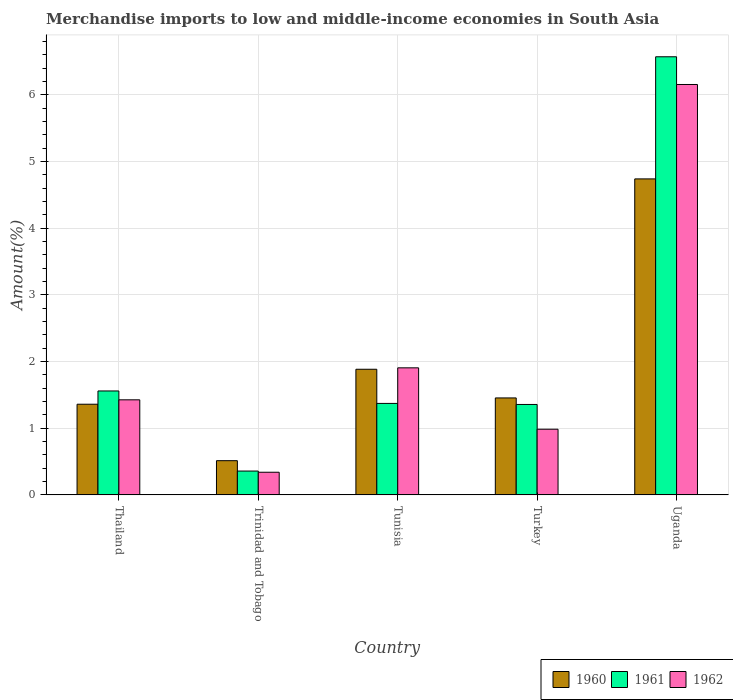How many different coloured bars are there?
Keep it short and to the point. 3. How many groups of bars are there?
Make the answer very short. 5. Are the number of bars per tick equal to the number of legend labels?
Give a very brief answer. Yes. What is the label of the 3rd group of bars from the left?
Offer a very short reply. Tunisia. In how many cases, is the number of bars for a given country not equal to the number of legend labels?
Offer a very short reply. 0. What is the percentage of amount earned from merchandise imports in 1962 in Thailand?
Your answer should be very brief. 1.43. Across all countries, what is the maximum percentage of amount earned from merchandise imports in 1960?
Make the answer very short. 4.74. Across all countries, what is the minimum percentage of amount earned from merchandise imports in 1962?
Provide a short and direct response. 0.34. In which country was the percentage of amount earned from merchandise imports in 1960 maximum?
Offer a terse response. Uganda. In which country was the percentage of amount earned from merchandise imports in 1961 minimum?
Your response must be concise. Trinidad and Tobago. What is the total percentage of amount earned from merchandise imports in 1961 in the graph?
Make the answer very short. 11.21. What is the difference between the percentage of amount earned from merchandise imports in 1962 in Trinidad and Tobago and that in Uganda?
Ensure brevity in your answer.  -5.81. What is the difference between the percentage of amount earned from merchandise imports in 1961 in Turkey and the percentage of amount earned from merchandise imports in 1960 in Trinidad and Tobago?
Your answer should be compact. 0.84. What is the average percentage of amount earned from merchandise imports in 1960 per country?
Give a very brief answer. 1.99. What is the difference between the percentage of amount earned from merchandise imports of/in 1962 and percentage of amount earned from merchandise imports of/in 1961 in Thailand?
Ensure brevity in your answer.  -0.13. In how many countries, is the percentage of amount earned from merchandise imports in 1962 greater than 3.4 %?
Your answer should be very brief. 1. What is the ratio of the percentage of amount earned from merchandise imports in 1961 in Thailand to that in Tunisia?
Ensure brevity in your answer.  1.14. Is the percentage of amount earned from merchandise imports in 1961 in Thailand less than that in Turkey?
Your answer should be compact. No. Is the difference between the percentage of amount earned from merchandise imports in 1962 in Trinidad and Tobago and Tunisia greater than the difference between the percentage of amount earned from merchandise imports in 1961 in Trinidad and Tobago and Tunisia?
Keep it short and to the point. No. What is the difference between the highest and the second highest percentage of amount earned from merchandise imports in 1961?
Offer a very short reply. 0.19. What is the difference between the highest and the lowest percentage of amount earned from merchandise imports in 1962?
Provide a short and direct response. 5.81. What does the 1st bar from the right in Thailand represents?
Offer a very short reply. 1962. Is it the case that in every country, the sum of the percentage of amount earned from merchandise imports in 1960 and percentage of amount earned from merchandise imports in 1961 is greater than the percentage of amount earned from merchandise imports in 1962?
Provide a short and direct response. Yes. How many countries are there in the graph?
Your response must be concise. 5. What is the difference between two consecutive major ticks on the Y-axis?
Make the answer very short. 1. Does the graph contain grids?
Offer a terse response. Yes. Where does the legend appear in the graph?
Offer a very short reply. Bottom right. How are the legend labels stacked?
Make the answer very short. Horizontal. What is the title of the graph?
Offer a terse response. Merchandise imports to low and middle-income economies in South Asia. Does "1960" appear as one of the legend labels in the graph?
Offer a terse response. Yes. What is the label or title of the Y-axis?
Your response must be concise. Amount(%). What is the Amount(%) in 1960 in Thailand?
Provide a short and direct response. 1.36. What is the Amount(%) of 1961 in Thailand?
Ensure brevity in your answer.  1.56. What is the Amount(%) of 1962 in Thailand?
Provide a short and direct response. 1.43. What is the Amount(%) of 1960 in Trinidad and Tobago?
Ensure brevity in your answer.  0.51. What is the Amount(%) in 1961 in Trinidad and Tobago?
Ensure brevity in your answer.  0.36. What is the Amount(%) in 1962 in Trinidad and Tobago?
Your answer should be very brief. 0.34. What is the Amount(%) in 1960 in Tunisia?
Your response must be concise. 1.88. What is the Amount(%) of 1961 in Tunisia?
Your response must be concise. 1.37. What is the Amount(%) of 1962 in Tunisia?
Provide a short and direct response. 1.91. What is the Amount(%) in 1960 in Turkey?
Your answer should be very brief. 1.45. What is the Amount(%) in 1961 in Turkey?
Keep it short and to the point. 1.36. What is the Amount(%) in 1962 in Turkey?
Offer a terse response. 0.98. What is the Amount(%) in 1960 in Uganda?
Your answer should be very brief. 4.74. What is the Amount(%) of 1961 in Uganda?
Provide a succinct answer. 6.57. What is the Amount(%) in 1962 in Uganda?
Provide a succinct answer. 6.15. Across all countries, what is the maximum Amount(%) in 1960?
Make the answer very short. 4.74. Across all countries, what is the maximum Amount(%) in 1961?
Ensure brevity in your answer.  6.57. Across all countries, what is the maximum Amount(%) of 1962?
Offer a very short reply. 6.15. Across all countries, what is the minimum Amount(%) of 1960?
Your answer should be compact. 0.51. Across all countries, what is the minimum Amount(%) in 1961?
Provide a short and direct response. 0.36. Across all countries, what is the minimum Amount(%) of 1962?
Make the answer very short. 0.34. What is the total Amount(%) of 1960 in the graph?
Provide a short and direct response. 9.95. What is the total Amount(%) of 1961 in the graph?
Provide a short and direct response. 11.21. What is the total Amount(%) of 1962 in the graph?
Ensure brevity in your answer.  10.81. What is the difference between the Amount(%) in 1960 in Thailand and that in Trinidad and Tobago?
Provide a short and direct response. 0.85. What is the difference between the Amount(%) in 1961 in Thailand and that in Trinidad and Tobago?
Your response must be concise. 1.2. What is the difference between the Amount(%) of 1962 in Thailand and that in Trinidad and Tobago?
Provide a short and direct response. 1.09. What is the difference between the Amount(%) of 1960 in Thailand and that in Tunisia?
Keep it short and to the point. -0.52. What is the difference between the Amount(%) of 1961 in Thailand and that in Tunisia?
Provide a short and direct response. 0.19. What is the difference between the Amount(%) of 1962 in Thailand and that in Tunisia?
Your response must be concise. -0.48. What is the difference between the Amount(%) in 1960 in Thailand and that in Turkey?
Your answer should be very brief. -0.09. What is the difference between the Amount(%) in 1961 in Thailand and that in Turkey?
Give a very brief answer. 0.2. What is the difference between the Amount(%) of 1962 in Thailand and that in Turkey?
Your response must be concise. 0.44. What is the difference between the Amount(%) of 1960 in Thailand and that in Uganda?
Give a very brief answer. -3.38. What is the difference between the Amount(%) of 1961 in Thailand and that in Uganda?
Your answer should be very brief. -5.01. What is the difference between the Amount(%) in 1962 in Thailand and that in Uganda?
Provide a succinct answer. -4.73. What is the difference between the Amount(%) of 1960 in Trinidad and Tobago and that in Tunisia?
Your answer should be very brief. -1.37. What is the difference between the Amount(%) in 1961 in Trinidad and Tobago and that in Tunisia?
Provide a short and direct response. -1.01. What is the difference between the Amount(%) in 1962 in Trinidad and Tobago and that in Tunisia?
Give a very brief answer. -1.57. What is the difference between the Amount(%) in 1960 in Trinidad and Tobago and that in Turkey?
Ensure brevity in your answer.  -0.94. What is the difference between the Amount(%) of 1961 in Trinidad and Tobago and that in Turkey?
Your response must be concise. -1. What is the difference between the Amount(%) in 1962 in Trinidad and Tobago and that in Turkey?
Your response must be concise. -0.65. What is the difference between the Amount(%) of 1960 in Trinidad and Tobago and that in Uganda?
Make the answer very short. -4.23. What is the difference between the Amount(%) in 1961 in Trinidad and Tobago and that in Uganda?
Ensure brevity in your answer.  -6.21. What is the difference between the Amount(%) of 1962 in Trinidad and Tobago and that in Uganda?
Give a very brief answer. -5.81. What is the difference between the Amount(%) of 1960 in Tunisia and that in Turkey?
Provide a succinct answer. 0.43. What is the difference between the Amount(%) in 1961 in Tunisia and that in Turkey?
Make the answer very short. 0.02. What is the difference between the Amount(%) in 1962 in Tunisia and that in Turkey?
Your response must be concise. 0.92. What is the difference between the Amount(%) of 1960 in Tunisia and that in Uganda?
Your answer should be compact. -2.85. What is the difference between the Amount(%) in 1961 in Tunisia and that in Uganda?
Provide a short and direct response. -5.2. What is the difference between the Amount(%) in 1962 in Tunisia and that in Uganda?
Your answer should be compact. -4.25. What is the difference between the Amount(%) of 1960 in Turkey and that in Uganda?
Ensure brevity in your answer.  -3.28. What is the difference between the Amount(%) of 1961 in Turkey and that in Uganda?
Keep it short and to the point. -5.21. What is the difference between the Amount(%) of 1962 in Turkey and that in Uganda?
Your answer should be compact. -5.17. What is the difference between the Amount(%) in 1960 in Thailand and the Amount(%) in 1961 in Trinidad and Tobago?
Your response must be concise. 1. What is the difference between the Amount(%) of 1960 in Thailand and the Amount(%) of 1962 in Trinidad and Tobago?
Give a very brief answer. 1.02. What is the difference between the Amount(%) of 1961 in Thailand and the Amount(%) of 1962 in Trinidad and Tobago?
Your response must be concise. 1.22. What is the difference between the Amount(%) of 1960 in Thailand and the Amount(%) of 1961 in Tunisia?
Your response must be concise. -0.01. What is the difference between the Amount(%) of 1960 in Thailand and the Amount(%) of 1962 in Tunisia?
Make the answer very short. -0.55. What is the difference between the Amount(%) of 1961 in Thailand and the Amount(%) of 1962 in Tunisia?
Keep it short and to the point. -0.35. What is the difference between the Amount(%) in 1960 in Thailand and the Amount(%) in 1961 in Turkey?
Offer a very short reply. 0. What is the difference between the Amount(%) in 1960 in Thailand and the Amount(%) in 1962 in Turkey?
Provide a short and direct response. 0.37. What is the difference between the Amount(%) of 1961 in Thailand and the Amount(%) of 1962 in Turkey?
Give a very brief answer. 0.57. What is the difference between the Amount(%) of 1960 in Thailand and the Amount(%) of 1961 in Uganda?
Keep it short and to the point. -5.21. What is the difference between the Amount(%) in 1960 in Thailand and the Amount(%) in 1962 in Uganda?
Your answer should be very brief. -4.79. What is the difference between the Amount(%) in 1961 in Thailand and the Amount(%) in 1962 in Uganda?
Your response must be concise. -4.6. What is the difference between the Amount(%) in 1960 in Trinidad and Tobago and the Amount(%) in 1961 in Tunisia?
Offer a very short reply. -0.86. What is the difference between the Amount(%) of 1960 in Trinidad and Tobago and the Amount(%) of 1962 in Tunisia?
Provide a short and direct response. -1.39. What is the difference between the Amount(%) in 1961 in Trinidad and Tobago and the Amount(%) in 1962 in Tunisia?
Offer a very short reply. -1.55. What is the difference between the Amount(%) in 1960 in Trinidad and Tobago and the Amount(%) in 1961 in Turkey?
Your answer should be compact. -0.84. What is the difference between the Amount(%) in 1960 in Trinidad and Tobago and the Amount(%) in 1962 in Turkey?
Ensure brevity in your answer.  -0.47. What is the difference between the Amount(%) in 1961 in Trinidad and Tobago and the Amount(%) in 1962 in Turkey?
Ensure brevity in your answer.  -0.63. What is the difference between the Amount(%) of 1960 in Trinidad and Tobago and the Amount(%) of 1961 in Uganda?
Your answer should be compact. -6.06. What is the difference between the Amount(%) in 1960 in Trinidad and Tobago and the Amount(%) in 1962 in Uganda?
Make the answer very short. -5.64. What is the difference between the Amount(%) of 1961 in Trinidad and Tobago and the Amount(%) of 1962 in Uganda?
Provide a succinct answer. -5.8. What is the difference between the Amount(%) of 1960 in Tunisia and the Amount(%) of 1961 in Turkey?
Give a very brief answer. 0.53. What is the difference between the Amount(%) of 1960 in Tunisia and the Amount(%) of 1962 in Turkey?
Keep it short and to the point. 0.9. What is the difference between the Amount(%) in 1961 in Tunisia and the Amount(%) in 1962 in Turkey?
Keep it short and to the point. 0.39. What is the difference between the Amount(%) in 1960 in Tunisia and the Amount(%) in 1961 in Uganda?
Provide a succinct answer. -4.69. What is the difference between the Amount(%) in 1960 in Tunisia and the Amount(%) in 1962 in Uganda?
Offer a very short reply. -4.27. What is the difference between the Amount(%) in 1961 in Tunisia and the Amount(%) in 1962 in Uganda?
Your answer should be compact. -4.78. What is the difference between the Amount(%) of 1960 in Turkey and the Amount(%) of 1961 in Uganda?
Your answer should be compact. -5.12. What is the difference between the Amount(%) in 1960 in Turkey and the Amount(%) in 1962 in Uganda?
Keep it short and to the point. -4.7. What is the difference between the Amount(%) of 1961 in Turkey and the Amount(%) of 1962 in Uganda?
Ensure brevity in your answer.  -4.8. What is the average Amount(%) of 1960 per country?
Your answer should be very brief. 1.99. What is the average Amount(%) of 1961 per country?
Offer a terse response. 2.24. What is the average Amount(%) in 1962 per country?
Keep it short and to the point. 2.16. What is the difference between the Amount(%) in 1960 and Amount(%) in 1961 in Thailand?
Your answer should be very brief. -0.2. What is the difference between the Amount(%) in 1960 and Amount(%) in 1962 in Thailand?
Your answer should be very brief. -0.07. What is the difference between the Amount(%) of 1961 and Amount(%) of 1962 in Thailand?
Your answer should be compact. 0.13. What is the difference between the Amount(%) of 1960 and Amount(%) of 1961 in Trinidad and Tobago?
Your answer should be very brief. 0.16. What is the difference between the Amount(%) of 1960 and Amount(%) of 1962 in Trinidad and Tobago?
Offer a terse response. 0.17. What is the difference between the Amount(%) in 1961 and Amount(%) in 1962 in Trinidad and Tobago?
Your answer should be compact. 0.02. What is the difference between the Amount(%) of 1960 and Amount(%) of 1961 in Tunisia?
Ensure brevity in your answer.  0.51. What is the difference between the Amount(%) of 1960 and Amount(%) of 1962 in Tunisia?
Your answer should be very brief. -0.02. What is the difference between the Amount(%) of 1961 and Amount(%) of 1962 in Tunisia?
Offer a terse response. -0.53. What is the difference between the Amount(%) in 1960 and Amount(%) in 1961 in Turkey?
Your response must be concise. 0.1. What is the difference between the Amount(%) of 1960 and Amount(%) of 1962 in Turkey?
Offer a very short reply. 0.47. What is the difference between the Amount(%) of 1961 and Amount(%) of 1962 in Turkey?
Your response must be concise. 0.37. What is the difference between the Amount(%) of 1960 and Amount(%) of 1961 in Uganda?
Your answer should be compact. -1.83. What is the difference between the Amount(%) of 1960 and Amount(%) of 1962 in Uganda?
Offer a very short reply. -1.42. What is the difference between the Amount(%) of 1961 and Amount(%) of 1962 in Uganda?
Your answer should be compact. 0.42. What is the ratio of the Amount(%) in 1960 in Thailand to that in Trinidad and Tobago?
Your response must be concise. 2.65. What is the ratio of the Amount(%) in 1961 in Thailand to that in Trinidad and Tobago?
Your answer should be very brief. 4.36. What is the ratio of the Amount(%) in 1962 in Thailand to that in Trinidad and Tobago?
Make the answer very short. 4.2. What is the ratio of the Amount(%) of 1960 in Thailand to that in Tunisia?
Make the answer very short. 0.72. What is the ratio of the Amount(%) in 1961 in Thailand to that in Tunisia?
Provide a succinct answer. 1.14. What is the ratio of the Amount(%) in 1962 in Thailand to that in Tunisia?
Provide a succinct answer. 0.75. What is the ratio of the Amount(%) of 1960 in Thailand to that in Turkey?
Provide a succinct answer. 0.94. What is the ratio of the Amount(%) in 1961 in Thailand to that in Turkey?
Make the answer very short. 1.15. What is the ratio of the Amount(%) in 1962 in Thailand to that in Turkey?
Your response must be concise. 1.45. What is the ratio of the Amount(%) in 1960 in Thailand to that in Uganda?
Provide a succinct answer. 0.29. What is the ratio of the Amount(%) of 1961 in Thailand to that in Uganda?
Your answer should be compact. 0.24. What is the ratio of the Amount(%) in 1962 in Thailand to that in Uganda?
Keep it short and to the point. 0.23. What is the ratio of the Amount(%) in 1960 in Trinidad and Tobago to that in Tunisia?
Your answer should be very brief. 0.27. What is the ratio of the Amount(%) of 1961 in Trinidad and Tobago to that in Tunisia?
Offer a terse response. 0.26. What is the ratio of the Amount(%) in 1962 in Trinidad and Tobago to that in Tunisia?
Your answer should be compact. 0.18. What is the ratio of the Amount(%) in 1960 in Trinidad and Tobago to that in Turkey?
Keep it short and to the point. 0.35. What is the ratio of the Amount(%) in 1961 in Trinidad and Tobago to that in Turkey?
Give a very brief answer. 0.26. What is the ratio of the Amount(%) of 1962 in Trinidad and Tobago to that in Turkey?
Offer a terse response. 0.34. What is the ratio of the Amount(%) of 1960 in Trinidad and Tobago to that in Uganda?
Your response must be concise. 0.11. What is the ratio of the Amount(%) of 1961 in Trinidad and Tobago to that in Uganda?
Give a very brief answer. 0.05. What is the ratio of the Amount(%) of 1962 in Trinidad and Tobago to that in Uganda?
Give a very brief answer. 0.06. What is the ratio of the Amount(%) of 1960 in Tunisia to that in Turkey?
Keep it short and to the point. 1.3. What is the ratio of the Amount(%) in 1961 in Tunisia to that in Turkey?
Provide a short and direct response. 1.01. What is the ratio of the Amount(%) of 1962 in Tunisia to that in Turkey?
Give a very brief answer. 1.93. What is the ratio of the Amount(%) of 1960 in Tunisia to that in Uganda?
Provide a short and direct response. 0.4. What is the ratio of the Amount(%) in 1961 in Tunisia to that in Uganda?
Make the answer very short. 0.21. What is the ratio of the Amount(%) in 1962 in Tunisia to that in Uganda?
Offer a terse response. 0.31. What is the ratio of the Amount(%) in 1960 in Turkey to that in Uganda?
Give a very brief answer. 0.31. What is the ratio of the Amount(%) of 1961 in Turkey to that in Uganda?
Your answer should be compact. 0.21. What is the ratio of the Amount(%) of 1962 in Turkey to that in Uganda?
Your answer should be compact. 0.16. What is the difference between the highest and the second highest Amount(%) in 1960?
Your answer should be very brief. 2.85. What is the difference between the highest and the second highest Amount(%) in 1961?
Give a very brief answer. 5.01. What is the difference between the highest and the second highest Amount(%) in 1962?
Your response must be concise. 4.25. What is the difference between the highest and the lowest Amount(%) of 1960?
Your response must be concise. 4.23. What is the difference between the highest and the lowest Amount(%) in 1961?
Offer a very short reply. 6.21. What is the difference between the highest and the lowest Amount(%) of 1962?
Provide a succinct answer. 5.81. 